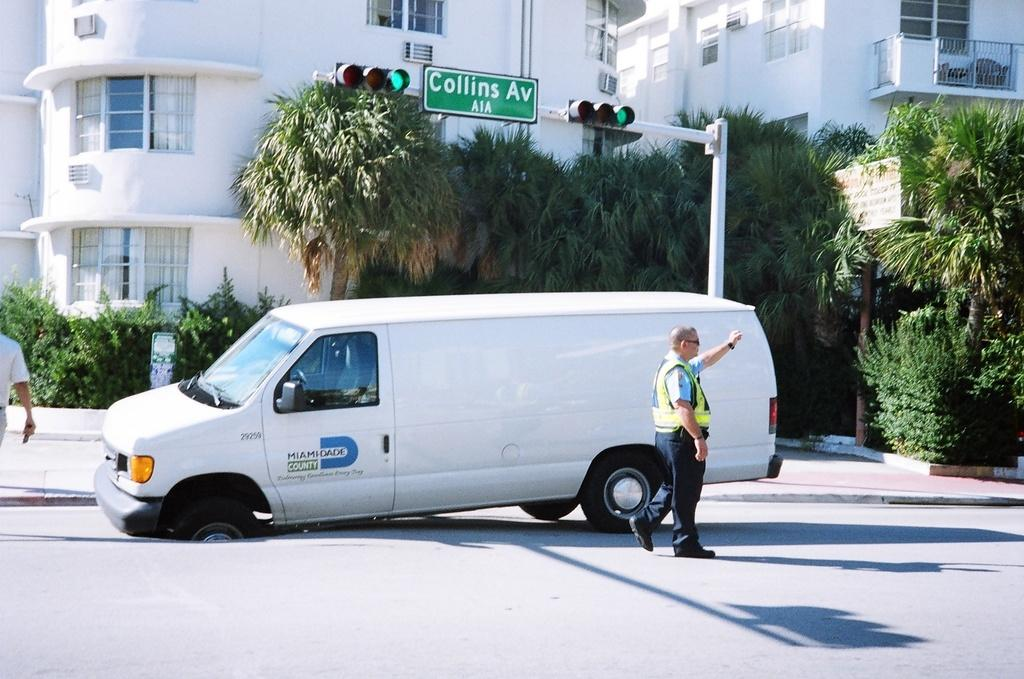<image>
Render a clear and concise summary of the photo. A white van has a deflated tire under the street sign that reads collins avenue. 